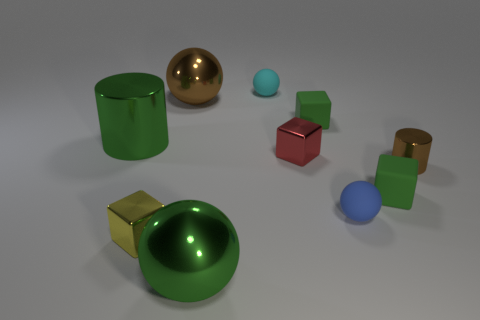Subtract all gray spheres. Subtract all red blocks. How many spheres are left? 4 Subtract all cylinders. How many objects are left? 8 Subtract all tiny yellow objects. Subtract all tiny matte spheres. How many objects are left? 7 Add 1 green things. How many green things are left? 5 Add 7 tiny red things. How many tiny red things exist? 8 Subtract 0 purple balls. How many objects are left? 10 